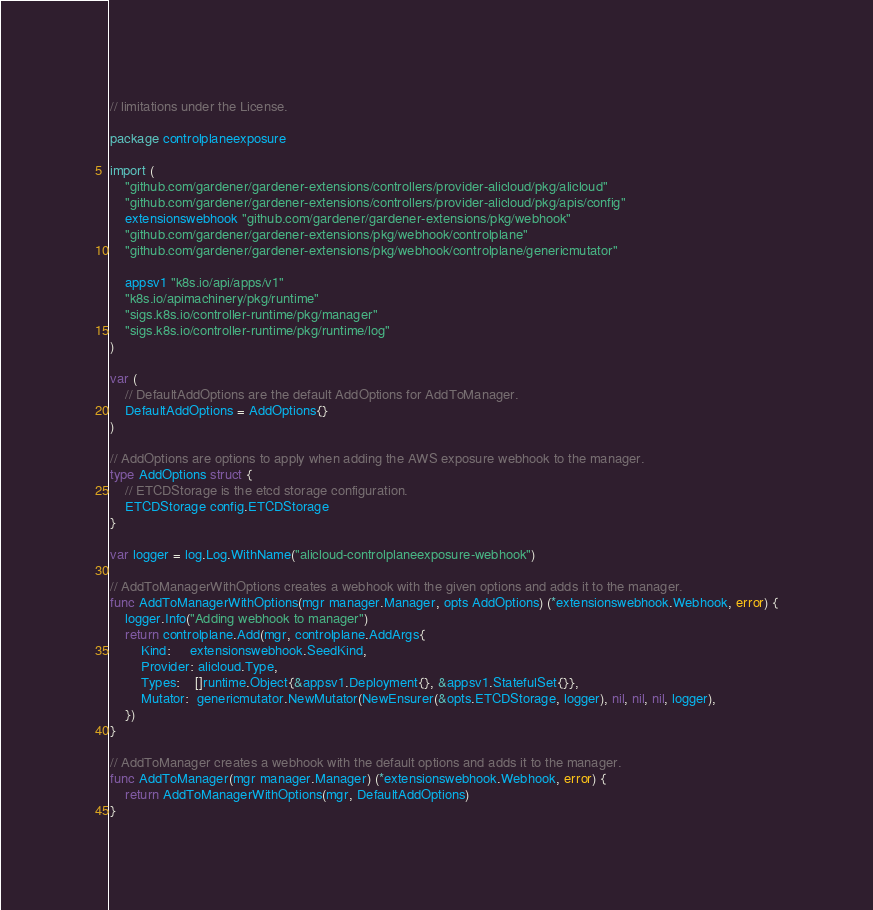<code> <loc_0><loc_0><loc_500><loc_500><_Go_>// limitations under the License.

package controlplaneexposure

import (
	"github.com/gardener/gardener-extensions/controllers/provider-alicloud/pkg/alicloud"
	"github.com/gardener/gardener-extensions/controllers/provider-alicloud/pkg/apis/config"
	extensionswebhook "github.com/gardener/gardener-extensions/pkg/webhook"
	"github.com/gardener/gardener-extensions/pkg/webhook/controlplane"
	"github.com/gardener/gardener-extensions/pkg/webhook/controlplane/genericmutator"

	appsv1 "k8s.io/api/apps/v1"
	"k8s.io/apimachinery/pkg/runtime"
	"sigs.k8s.io/controller-runtime/pkg/manager"
	"sigs.k8s.io/controller-runtime/pkg/runtime/log"
)

var (
	// DefaultAddOptions are the default AddOptions for AddToManager.
	DefaultAddOptions = AddOptions{}
)

// AddOptions are options to apply when adding the AWS exposure webhook to the manager.
type AddOptions struct {
	// ETCDStorage is the etcd storage configuration.
	ETCDStorage config.ETCDStorage
}

var logger = log.Log.WithName("alicloud-controlplaneexposure-webhook")

// AddToManagerWithOptions creates a webhook with the given options and adds it to the manager.
func AddToManagerWithOptions(mgr manager.Manager, opts AddOptions) (*extensionswebhook.Webhook, error) {
	logger.Info("Adding webhook to manager")
	return controlplane.Add(mgr, controlplane.AddArgs{
		Kind:     extensionswebhook.SeedKind,
		Provider: alicloud.Type,
		Types:    []runtime.Object{&appsv1.Deployment{}, &appsv1.StatefulSet{}},
		Mutator:  genericmutator.NewMutator(NewEnsurer(&opts.ETCDStorage, logger), nil, nil, nil, logger),
	})
}

// AddToManager creates a webhook with the default options and adds it to the manager.
func AddToManager(mgr manager.Manager) (*extensionswebhook.Webhook, error) {
	return AddToManagerWithOptions(mgr, DefaultAddOptions)
}
</code> 